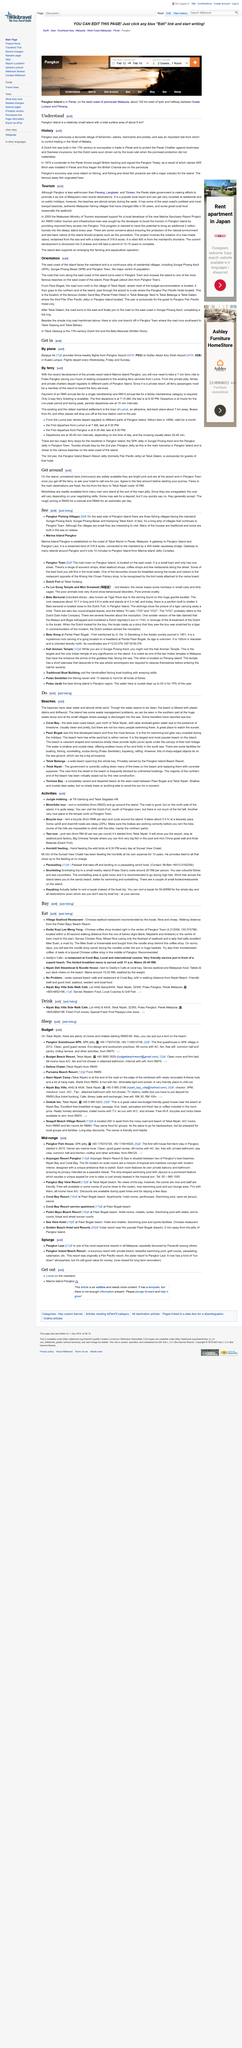Indicate a few pertinent items in this graphic. The cost of a trip from the ferry to Teluk Nipah is 16 RM. The Dutch were driven out because the protection they were promised did not materialize, causing them to lose faith in the system. There are two options for getting around, namely taxis and motorbikes, which provide convenient and efficient transportation in Hoi An. In 1874, a contender to the Perak throne sought British backing and signed the Pangkor Treaty, which granted the British the right to protect the contender and enable them to assume the throne. Pangkor Island, with a total surface area of about 8km, was a favored refuge for fishermen, sailors, merchants, and pirates in the past. 